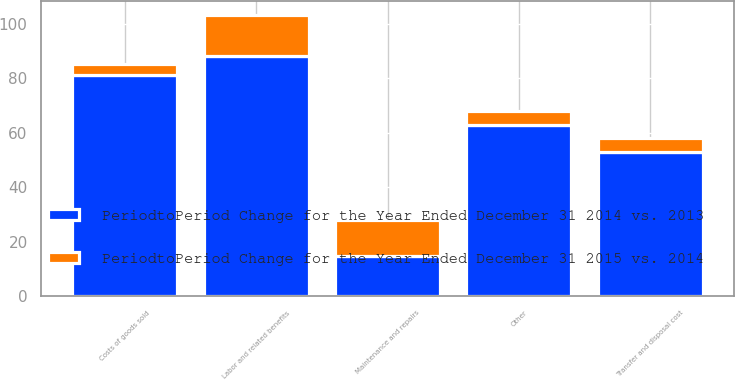<chart> <loc_0><loc_0><loc_500><loc_500><stacked_bar_chart><ecel><fcel>Maintenance and repairs<fcel>Labor and related benefits<fcel>Costs of goods sold<fcel>Other<fcel>Transfer and disposal cost<nl><fcel>PeriodtoPeriod Change for the Year Ended December 31 2014 vs. 2013<fcel>15<fcel>88<fcel>81<fcel>63<fcel>53<nl><fcel>PeriodtoPeriod Change for the Year Ended December 31 2015 vs. 2014<fcel>13<fcel>15<fcel>4<fcel>5<fcel>5<nl></chart> 